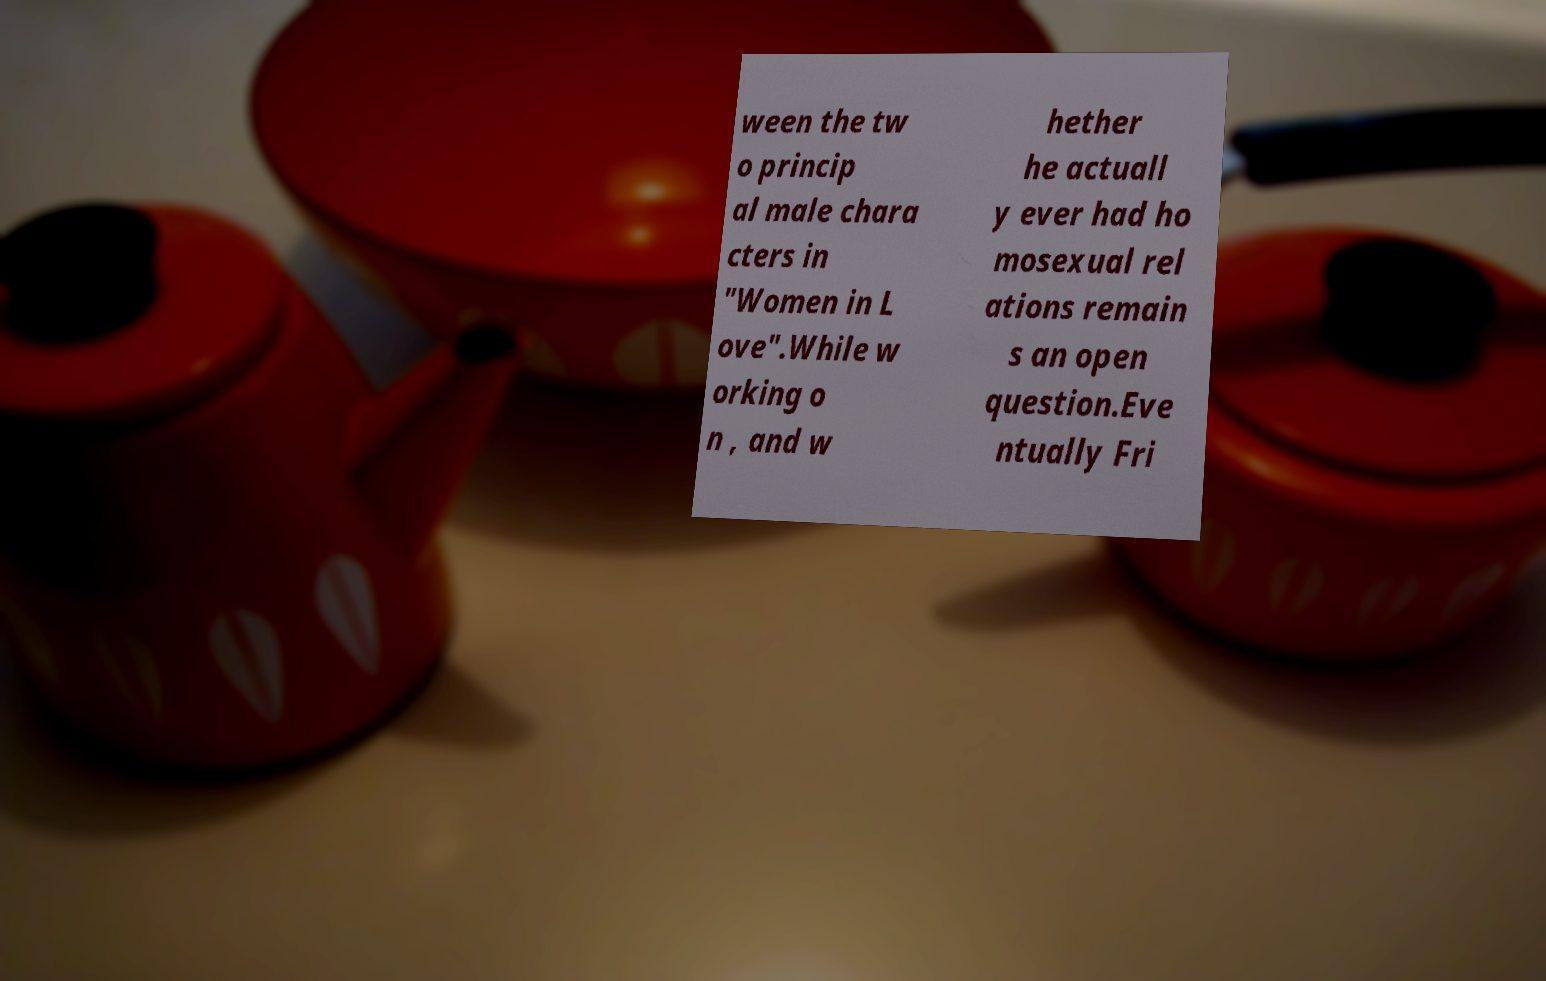For documentation purposes, I need the text within this image transcribed. Could you provide that? ween the tw o princip al male chara cters in "Women in L ove".While w orking o n , and w hether he actuall y ever had ho mosexual rel ations remain s an open question.Eve ntually Fri 